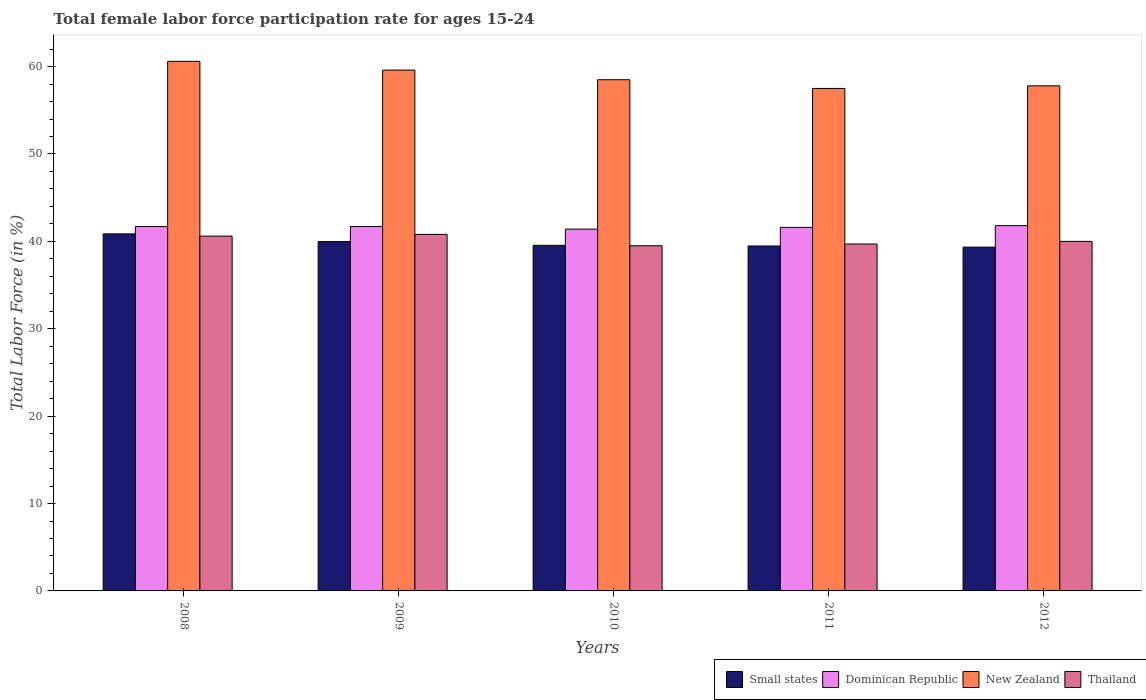How many bars are there on the 1st tick from the right?
Your response must be concise. 4. In how many cases, is the number of bars for a given year not equal to the number of legend labels?
Offer a terse response. 0. What is the female labor force participation rate in Thailand in 2009?
Your response must be concise. 40.8. Across all years, what is the maximum female labor force participation rate in Dominican Republic?
Ensure brevity in your answer.  41.8. Across all years, what is the minimum female labor force participation rate in Thailand?
Your answer should be very brief. 39.5. In which year was the female labor force participation rate in Small states maximum?
Offer a terse response. 2008. What is the total female labor force participation rate in New Zealand in the graph?
Offer a very short reply. 294. What is the difference between the female labor force participation rate in Thailand in 2009 and that in 2012?
Ensure brevity in your answer.  0.8. What is the difference between the female labor force participation rate in New Zealand in 2011 and the female labor force participation rate in Small states in 2012?
Make the answer very short. 18.16. What is the average female labor force participation rate in New Zealand per year?
Your answer should be compact. 58.8. In the year 2012, what is the difference between the female labor force participation rate in Thailand and female labor force participation rate in Dominican Republic?
Give a very brief answer. -1.8. What is the ratio of the female labor force participation rate in Thailand in 2009 to that in 2010?
Ensure brevity in your answer.  1.03. Is the difference between the female labor force participation rate in Thailand in 2009 and 2011 greater than the difference between the female labor force participation rate in Dominican Republic in 2009 and 2011?
Provide a succinct answer. Yes. What is the difference between the highest and the second highest female labor force participation rate in Small states?
Your answer should be very brief. 0.88. What is the difference between the highest and the lowest female labor force participation rate in Dominican Republic?
Your response must be concise. 0.4. In how many years, is the female labor force participation rate in Small states greater than the average female labor force participation rate in Small states taken over all years?
Offer a terse response. 2. Is the sum of the female labor force participation rate in Thailand in 2009 and 2012 greater than the maximum female labor force participation rate in Dominican Republic across all years?
Your answer should be compact. Yes. What does the 2nd bar from the left in 2010 represents?
Ensure brevity in your answer.  Dominican Republic. What does the 1st bar from the right in 2009 represents?
Provide a short and direct response. Thailand. Is it the case that in every year, the sum of the female labor force participation rate in Thailand and female labor force participation rate in Dominican Republic is greater than the female labor force participation rate in Small states?
Provide a succinct answer. Yes. How many bars are there?
Ensure brevity in your answer.  20. How many years are there in the graph?
Ensure brevity in your answer.  5. What is the difference between two consecutive major ticks on the Y-axis?
Your response must be concise. 10. Are the values on the major ticks of Y-axis written in scientific E-notation?
Your answer should be compact. No. Does the graph contain any zero values?
Ensure brevity in your answer.  No. How are the legend labels stacked?
Your answer should be compact. Horizontal. What is the title of the graph?
Your answer should be very brief. Total female labor force participation rate for ages 15-24. Does "United Arab Emirates" appear as one of the legend labels in the graph?
Make the answer very short. No. What is the label or title of the Y-axis?
Keep it short and to the point. Total Labor Force (in %). What is the Total Labor Force (in %) in Small states in 2008?
Make the answer very short. 40.86. What is the Total Labor Force (in %) of Dominican Republic in 2008?
Keep it short and to the point. 41.7. What is the Total Labor Force (in %) of New Zealand in 2008?
Provide a succinct answer. 60.6. What is the Total Labor Force (in %) in Thailand in 2008?
Make the answer very short. 40.6. What is the Total Labor Force (in %) in Small states in 2009?
Provide a short and direct response. 39.97. What is the Total Labor Force (in %) of Dominican Republic in 2009?
Provide a succinct answer. 41.7. What is the Total Labor Force (in %) in New Zealand in 2009?
Your answer should be very brief. 59.6. What is the Total Labor Force (in %) of Thailand in 2009?
Your answer should be very brief. 40.8. What is the Total Labor Force (in %) of Small states in 2010?
Provide a short and direct response. 39.54. What is the Total Labor Force (in %) of Dominican Republic in 2010?
Give a very brief answer. 41.4. What is the Total Labor Force (in %) of New Zealand in 2010?
Your answer should be compact. 58.5. What is the Total Labor Force (in %) of Thailand in 2010?
Your answer should be compact. 39.5. What is the Total Labor Force (in %) of Small states in 2011?
Make the answer very short. 39.47. What is the Total Labor Force (in %) in Dominican Republic in 2011?
Ensure brevity in your answer.  41.6. What is the Total Labor Force (in %) in New Zealand in 2011?
Give a very brief answer. 57.5. What is the Total Labor Force (in %) in Thailand in 2011?
Keep it short and to the point. 39.7. What is the Total Labor Force (in %) in Small states in 2012?
Ensure brevity in your answer.  39.34. What is the Total Labor Force (in %) in Dominican Republic in 2012?
Your answer should be very brief. 41.8. What is the Total Labor Force (in %) in New Zealand in 2012?
Offer a terse response. 57.8. What is the Total Labor Force (in %) of Thailand in 2012?
Provide a short and direct response. 40. Across all years, what is the maximum Total Labor Force (in %) in Small states?
Offer a terse response. 40.86. Across all years, what is the maximum Total Labor Force (in %) in Dominican Republic?
Provide a short and direct response. 41.8. Across all years, what is the maximum Total Labor Force (in %) in New Zealand?
Your answer should be compact. 60.6. Across all years, what is the maximum Total Labor Force (in %) of Thailand?
Offer a very short reply. 40.8. Across all years, what is the minimum Total Labor Force (in %) in Small states?
Ensure brevity in your answer.  39.34. Across all years, what is the minimum Total Labor Force (in %) in Dominican Republic?
Ensure brevity in your answer.  41.4. Across all years, what is the minimum Total Labor Force (in %) in New Zealand?
Offer a very short reply. 57.5. Across all years, what is the minimum Total Labor Force (in %) in Thailand?
Keep it short and to the point. 39.5. What is the total Total Labor Force (in %) of Small states in the graph?
Keep it short and to the point. 199.19. What is the total Total Labor Force (in %) of Dominican Republic in the graph?
Offer a terse response. 208.2. What is the total Total Labor Force (in %) in New Zealand in the graph?
Give a very brief answer. 294. What is the total Total Labor Force (in %) of Thailand in the graph?
Your answer should be very brief. 200.6. What is the difference between the Total Labor Force (in %) of Small states in 2008 and that in 2009?
Offer a very short reply. 0.88. What is the difference between the Total Labor Force (in %) of Dominican Republic in 2008 and that in 2009?
Keep it short and to the point. 0. What is the difference between the Total Labor Force (in %) of New Zealand in 2008 and that in 2009?
Your answer should be very brief. 1. What is the difference between the Total Labor Force (in %) in Small states in 2008 and that in 2010?
Keep it short and to the point. 1.31. What is the difference between the Total Labor Force (in %) of Small states in 2008 and that in 2011?
Ensure brevity in your answer.  1.39. What is the difference between the Total Labor Force (in %) in Dominican Republic in 2008 and that in 2011?
Your answer should be compact. 0.1. What is the difference between the Total Labor Force (in %) in New Zealand in 2008 and that in 2011?
Offer a very short reply. 3.1. What is the difference between the Total Labor Force (in %) in Small states in 2008 and that in 2012?
Offer a very short reply. 1.52. What is the difference between the Total Labor Force (in %) of Dominican Republic in 2008 and that in 2012?
Your answer should be very brief. -0.1. What is the difference between the Total Labor Force (in %) of Small states in 2009 and that in 2010?
Provide a short and direct response. 0.43. What is the difference between the Total Labor Force (in %) in Thailand in 2009 and that in 2010?
Ensure brevity in your answer.  1.3. What is the difference between the Total Labor Force (in %) in Small states in 2009 and that in 2011?
Your answer should be very brief. 0.5. What is the difference between the Total Labor Force (in %) in New Zealand in 2009 and that in 2011?
Offer a terse response. 2.1. What is the difference between the Total Labor Force (in %) of Small states in 2009 and that in 2012?
Offer a terse response. 0.63. What is the difference between the Total Labor Force (in %) in Small states in 2010 and that in 2011?
Your answer should be compact. 0.07. What is the difference between the Total Labor Force (in %) of Dominican Republic in 2010 and that in 2011?
Provide a succinct answer. -0.2. What is the difference between the Total Labor Force (in %) of Thailand in 2010 and that in 2011?
Make the answer very short. -0.2. What is the difference between the Total Labor Force (in %) of Small states in 2010 and that in 2012?
Make the answer very short. 0.2. What is the difference between the Total Labor Force (in %) of Dominican Republic in 2010 and that in 2012?
Keep it short and to the point. -0.4. What is the difference between the Total Labor Force (in %) in Small states in 2011 and that in 2012?
Your answer should be compact. 0.13. What is the difference between the Total Labor Force (in %) in New Zealand in 2011 and that in 2012?
Offer a terse response. -0.3. What is the difference between the Total Labor Force (in %) of Thailand in 2011 and that in 2012?
Give a very brief answer. -0.3. What is the difference between the Total Labor Force (in %) in Small states in 2008 and the Total Labor Force (in %) in Dominican Republic in 2009?
Provide a succinct answer. -0.84. What is the difference between the Total Labor Force (in %) of Small states in 2008 and the Total Labor Force (in %) of New Zealand in 2009?
Make the answer very short. -18.74. What is the difference between the Total Labor Force (in %) in Small states in 2008 and the Total Labor Force (in %) in Thailand in 2009?
Offer a very short reply. 0.06. What is the difference between the Total Labor Force (in %) in Dominican Republic in 2008 and the Total Labor Force (in %) in New Zealand in 2009?
Keep it short and to the point. -17.9. What is the difference between the Total Labor Force (in %) in New Zealand in 2008 and the Total Labor Force (in %) in Thailand in 2009?
Ensure brevity in your answer.  19.8. What is the difference between the Total Labor Force (in %) in Small states in 2008 and the Total Labor Force (in %) in Dominican Republic in 2010?
Offer a terse response. -0.54. What is the difference between the Total Labor Force (in %) in Small states in 2008 and the Total Labor Force (in %) in New Zealand in 2010?
Offer a terse response. -17.64. What is the difference between the Total Labor Force (in %) of Small states in 2008 and the Total Labor Force (in %) of Thailand in 2010?
Offer a very short reply. 1.36. What is the difference between the Total Labor Force (in %) of Dominican Republic in 2008 and the Total Labor Force (in %) of New Zealand in 2010?
Give a very brief answer. -16.8. What is the difference between the Total Labor Force (in %) in New Zealand in 2008 and the Total Labor Force (in %) in Thailand in 2010?
Offer a very short reply. 21.1. What is the difference between the Total Labor Force (in %) in Small states in 2008 and the Total Labor Force (in %) in Dominican Republic in 2011?
Ensure brevity in your answer.  -0.74. What is the difference between the Total Labor Force (in %) in Small states in 2008 and the Total Labor Force (in %) in New Zealand in 2011?
Keep it short and to the point. -16.64. What is the difference between the Total Labor Force (in %) in Small states in 2008 and the Total Labor Force (in %) in Thailand in 2011?
Offer a very short reply. 1.16. What is the difference between the Total Labor Force (in %) of Dominican Republic in 2008 and the Total Labor Force (in %) of New Zealand in 2011?
Make the answer very short. -15.8. What is the difference between the Total Labor Force (in %) of Dominican Republic in 2008 and the Total Labor Force (in %) of Thailand in 2011?
Ensure brevity in your answer.  2. What is the difference between the Total Labor Force (in %) of New Zealand in 2008 and the Total Labor Force (in %) of Thailand in 2011?
Give a very brief answer. 20.9. What is the difference between the Total Labor Force (in %) in Small states in 2008 and the Total Labor Force (in %) in Dominican Republic in 2012?
Keep it short and to the point. -0.94. What is the difference between the Total Labor Force (in %) of Small states in 2008 and the Total Labor Force (in %) of New Zealand in 2012?
Your response must be concise. -16.94. What is the difference between the Total Labor Force (in %) of Small states in 2008 and the Total Labor Force (in %) of Thailand in 2012?
Your answer should be very brief. 0.86. What is the difference between the Total Labor Force (in %) in Dominican Republic in 2008 and the Total Labor Force (in %) in New Zealand in 2012?
Your answer should be compact. -16.1. What is the difference between the Total Labor Force (in %) in Dominican Republic in 2008 and the Total Labor Force (in %) in Thailand in 2012?
Your answer should be compact. 1.7. What is the difference between the Total Labor Force (in %) of New Zealand in 2008 and the Total Labor Force (in %) of Thailand in 2012?
Provide a short and direct response. 20.6. What is the difference between the Total Labor Force (in %) of Small states in 2009 and the Total Labor Force (in %) of Dominican Republic in 2010?
Offer a terse response. -1.43. What is the difference between the Total Labor Force (in %) of Small states in 2009 and the Total Labor Force (in %) of New Zealand in 2010?
Provide a succinct answer. -18.53. What is the difference between the Total Labor Force (in %) in Small states in 2009 and the Total Labor Force (in %) in Thailand in 2010?
Ensure brevity in your answer.  0.47. What is the difference between the Total Labor Force (in %) of Dominican Republic in 2009 and the Total Labor Force (in %) of New Zealand in 2010?
Your response must be concise. -16.8. What is the difference between the Total Labor Force (in %) of New Zealand in 2009 and the Total Labor Force (in %) of Thailand in 2010?
Keep it short and to the point. 20.1. What is the difference between the Total Labor Force (in %) in Small states in 2009 and the Total Labor Force (in %) in Dominican Republic in 2011?
Provide a short and direct response. -1.63. What is the difference between the Total Labor Force (in %) in Small states in 2009 and the Total Labor Force (in %) in New Zealand in 2011?
Give a very brief answer. -17.53. What is the difference between the Total Labor Force (in %) in Small states in 2009 and the Total Labor Force (in %) in Thailand in 2011?
Offer a terse response. 0.27. What is the difference between the Total Labor Force (in %) in Dominican Republic in 2009 and the Total Labor Force (in %) in New Zealand in 2011?
Offer a very short reply. -15.8. What is the difference between the Total Labor Force (in %) in Dominican Republic in 2009 and the Total Labor Force (in %) in Thailand in 2011?
Provide a short and direct response. 2. What is the difference between the Total Labor Force (in %) of New Zealand in 2009 and the Total Labor Force (in %) of Thailand in 2011?
Ensure brevity in your answer.  19.9. What is the difference between the Total Labor Force (in %) of Small states in 2009 and the Total Labor Force (in %) of Dominican Republic in 2012?
Offer a terse response. -1.83. What is the difference between the Total Labor Force (in %) in Small states in 2009 and the Total Labor Force (in %) in New Zealand in 2012?
Your answer should be compact. -17.83. What is the difference between the Total Labor Force (in %) of Small states in 2009 and the Total Labor Force (in %) of Thailand in 2012?
Keep it short and to the point. -0.03. What is the difference between the Total Labor Force (in %) of Dominican Republic in 2009 and the Total Labor Force (in %) of New Zealand in 2012?
Keep it short and to the point. -16.1. What is the difference between the Total Labor Force (in %) of Dominican Republic in 2009 and the Total Labor Force (in %) of Thailand in 2012?
Provide a succinct answer. 1.7. What is the difference between the Total Labor Force (in %) of New Zealand in 2009 and the Total Labor Force (in %) of Thailand in 2012?
Provide a succinct answer. 19.6. What is the difference between the Total Labor Force (in %) of Small states in 2010 and the Total Labor Force (in %) of Dominican Republic in 2011?
Your answer should be very brief. -2.06. What is the difference between the Total Labor Force (in %) of Small states in 2010 and the Total Labor Force (in %) of New Zealand in 2011?
Make the answer very short. -17.96. What is the difference between the Total Labor Force (in %) in Small states in 2010 and the Total Labor Force (in %) in Thailand in 2011?
Make the answer very short. -0.16. What is the difference between the Total Labor Force (in %) in Dominican Republic in 2010 and the Total Labor Force (in %) in New Zealand in 2011?
Provide a succinct answer. -16.1. What is the difference between the Total Labor Force (in %) in Dominican Republic in 2010 and the Total Labor Force (in %) in Thailand in 2011?
Provide a succinct answer. 1.7. What is the difference between the Total Labor Force (in %) of New Zealand in 2010 and the Total Labor Force (in %) of Thailand in 2011?
Offer a very short reply. 18.8. What is the difference between the Total Labor Force (in %) of Small states in 2010 and the Total Labor Force (in %) of Dominican Republic in 2012?
Your answer should be very brief. -2.26. What is the difference between the Total Labor Force (in %) of Small states in 2010 and the Total Labor Force (in %) of New Zealand in 2012?
Give a very brief answer. -18.26. What is the difference between the Total Labor Force (in %) in Small states in 2010 and the Total Labor Force (in %) in Thailand in 2012?
Offer a terse response. -0.46. What is the difference between the Total Labor Force (in %) of Dominican Republic in 2010 and the Total Labor Force (in %) of New Zealand in 2012?
Give a very brief answer. -16.4. What is the difference between the Total Labor Force (in %) in New Zealand in 2010 and the Total Labor Force (in %) in Thailand in 2012?
Your answer should be very brief. 18.5. What is the difference between the Total Labor Force (in %) in Small states in 2011 and the Total Labor Force (in %) in Dominican Republic in 2012?
Your answer should be compact. -2.33. What is the difference between the Total Labor Force (in %) of Small states in 2011 and the Total Labor Force (in %) of New Zealand in 2012?
Make the answer very short. -18.33. What is the difference between the Total Labor Force (in %) of Small states in 2011 and the Total Labor Force (in %) of Thailand in 2012?
Your answer should be very brief. -0.53. What is the difference between the Total Labor Force (in %) in Dominican Republic in 2011 and the Total Labor Force (in %) in New Zealand in 2012?
Keep it short and to the point. -16.2. What is the difference between the Total Labor Force (in %) of New Zealand in 2011 and the Total Labor Force (in %) of Thailand in 2012?
Your response must be concise. 17.5. What is the average Total Labor Force (in %) of Small states per year?
Give a very brief answer. 39.84. What is the average Total Labor Force (in %) of Dominican Republic per year?
Ensure brevity in your answer.  41.64. What is the average Total Labor Force (in %) in New Zealand per year?
Your answer should be very brief. 58.8. What is the average Total Labor Force (in %) in Thailand per year?
Offer a very short reply. 40.12. In the year 2008, what is the difference between the Total Labor Force (in %) of Small states and Total Labor Force (in %) of Dominican Republic?
Offer a terse response. -0.84. In the year 2008, what is the difference between the Total Labor Force (in %) of Small states and Total Labor Force (in %) of New Zealand?
Provide a short and direct response. -19.74. In the year 2008, what is the difference between the Total Labor Force (in %) in Small states and Total Labor Force (in %) in Thailand?
Give a very brief answer. 0.26. In the year 2008, what is the difference between the Total Labor Force (in %) of Dominican Republic and Total Labor Force (in %) of New Zealand?
Make the answer very short. -18.9. In the year 2008, what is the difference between the Total Labor Force (in %) of Dominican Republic and Total Labor Force (in %) of Thailand?
Keep it short and to the point. 1.1. In the year 2008, what is the difference between the Total Labor Force (in %) in New Zealand and Total Labor Force (in %) in Thailand?
Your answer should be very brief. 20. In the year 2009, what is the difference between the Total Labor Force (in %) of Small states and Total Labor Force (in %) of Dominican Republic?
Make the answer very short. -1.73. In the year 2009, what is the difference between the Total Labor Force (in %) in Small states and Total Labor Force (in %) in New Zealand?
Your response must be concise. -19.63. In the year 2009, what is the difference between the Total Labor Force (in %) in Small states and Total Labor Force (in %) in Thailand?
Provide a short and direct response. -0.83. In the year 2009, what is the difference between the Total Labor Force (in %) of Dominican Republic and Total Labor Force (in %) of New Zealand?
Offer a terse response. -17.9. In the year 2009, what is the difference between the Total Labor Force (in %) of Dominican Republic and Total Labor Force (in %) of Thailand?
Offer a terse response. 0.9. In the year 2009, what is the difference between the Total Labor Force (in %) of New Zealand and Total Labor Force (in %) of Thailand?
Provide a short and direct response. 18.8. In the year 2010, what is the difference between the Total Labor Force (in %) in Small states and Total Labor Force (in %) in Dominican Republic?
Give a very brief answer. -1.86. In the year 2010, what is the difference between the Total Labor Force (in %) in Small states and Total Labor Force (in %) in New Zealand?
Your answer should be very brief. -18.96. In the year 2010, what is the difference between the Total Labor Force (in %) in Small states and Total Labor Force (in %) in Thailand?
Offer a terse response. 0.04. In the year 2010, what is the difference between the Total Labor Force (in %) of Dominican Republic and Total Labor Force (in %) of New Zealand?
Your response must be concise. -17.1. In the year 2010, what is the difference between the Total Labor Force (in %) in Dominican Republic and Total Labor Force (in %) in Thailand?
Your answer should be compact. 1.9. In the year 2010, what is the difference between the Total Labor Force (in %) in New Zealand and Total Labor Force (in %) in Thailand?
Your answer should be very brief. 19. In the year 2011, what is the difference between the Total Labor Force (in %) of Small states and Total Labor Force (in %) of Dominican Republic?
Offer a very short reply. -2.13. In the year 2011, what is the difference between the Total Labor Force (in %) of Small states and Total Labor Force (in %) of New Zealand?
Your answer should be very brief. -18.03. In the year 2011, what is the difference between the Total Labor Force (in %) of Small states and Total Labor Force (in %) of Thailand?
Provide a short and direct response. -0.23. In the year 2011, what is the difference between the Total Labor Force (in %) in Dominican Republic and Total Labor Force (in %) in New Zealand?
Your answer should be very brief. -15.9. In the year 2011, what is the difference between the Total Labor Force (in %) of New Zealand and Total Labor Force (in %) of Thailand?
Offer a terse response. 17.8. In the year 2012, what is the difference between the Total Labor Force (in %) of Small states and Total Labor Force (in %) of Dominican Republic?
Your answer should be compact. -2.46. In the year 2012, what is the difference between the Total Labor Force (in %) of Small states and Total Labor Force (in %) of New Zealand?
Make the answer very short. -18.46. In the year 2012, what is the difference between the Total Labor Force (in %) of Small states and Total Labor Force (in %) of Thailand?
Give a very brief answer. -0.66. In the year 2012, what is the difference between the Total Labor Force (in %) in New Zealand and Total Labor Force (in %) in Thailand?
Ensure brevity in your answer.  17.8. What is the ratio of the Total Labor Force (in %) in Small states in 2008 to that in 2009?
Keep it short and to the point. 1.02. What is the ratio of the Total Labor Force (in %) of Dominican Republic in 2008 to that in 2009?
Provide a short and direct response. 1. What is the ratio of the Total Labor Force (in %) of New Zealand in 2008 to that in 2009?
Ensure brevity in your answer.  1.02. What is the ratio of the Total Labor Force (in %) of Small states in 2008 to that in 2010?
Provide a short and direct response. 1.03. What is the ratio of the Total Labor Force (in %) of New Zealand in 2008 to that in 2010?
Provide a succinct answer. 1.04. What is the ratio of the Total Labor Force (in %) in Thailand in 2008 to that in 2010?
Offer a very short reply. 1.03. What is the ratio of the Total Labor Force (in %) of Small states in 2008 to that in 2011?
Give a very brief answer. 1.04. What is the ratio of the Total Labor Force (in %) in New Zealand in 2008 to that in 2011?
Ensure brevity in your answer.  1.05. What is the ratio of the Total Labor Force (in %) of Thailand in 2008 to that in 2011?
Offer a very short reply. 1.02. What is the ratio of the Total Labor Force (in %) of Small states in 2008 to that in 2012?
Offer a very short reply. 1.04. What is the ratio of the Total Labor Force (in %) of New Zealand in 2008 to that in 2012?
Your answer should be compact. 1.05. What is the ratio of the Total Labor Force (in %) of Small states in 2009 to that in 2010?
Make the answer very short. 1.01. What is the ratio of the Total Labor Force (in %) of Dominican Republic in 2009 to that in 2010?
Your response must be concise. 1.01. What is the ratio of the Total Labor Force (in %) in New Zealand in 2009 to that in 2010?
Ensure brevity in your answer.  1.02. What is the ratio of the Total Labor Force (in %) in Thailand in 2009 to that in 2010?
Your answer should be very brief. 1.03. What is the ratio of the Total Labor Force (in %) of Small states in 2009 to that in 2011?
Give a very brief answer. 1.01. What is the ratio of the Total Labor Force (in %) of New Zealand in 2009 to that in 2011?
Provide a succinct answer. 1.04. What is the ratio of the Total Labor Force (in %) in Thailand in 2009 to that in 2011?
Provide a succinct answer. 1.03. What is the ratio of the Total Labor Force (in %) of Small states in 2009 to that in 2012?
Offer a very short reply. 1.02. What is the ratio of the Total Labor Force (in %) of New Zealand in 2009 to that in 2012?
Provide a short and direct response. 1.03. What is the ratio of the Total Labor Force (in %) in Thailand in 2009 to that in 2012?
Offer a very short reply. 1.02. What is the ratio of the Total Labor Force (in %) in Dominican Republic in 2010 to that in 2011?
Provide a succinct answer. 1. What is the ratio of the Total Labor Force (in %) of New Zealand in 2010 to that in 2011?
Offer a very short reply. 1.02. What is the ratio of the Total Labor Force (in %) of Thailand in 2010 to that in 2011?
Your response must be concise. 0.99. What is the ratio of the Total Labor Force (in %) in Small states in 2010 to that in 2012?
Provide a succinct answer. 1.01. What is the ratio of the Total Labor Force (in %) of Dominican Republic in 2010 to that in 2012?
Your answer should be compact. 0.99. What is the ratio of the Total Labor Force (in %) in New Zealand in 2010 to that in 2012?
Offer a terse response. 1.01. What is the ratio of the Total Labor Force (in %) in Thailand in 2010 to that in 2012?
Ensure brevity in your answer.  0.99. What is the ratio of the Total Labor Force (in %) of Dominican Republic in 2011 to that in 2012?
Ensure brevity in your answer.  1. What is the ratio of the Total Labor Force (in %) of Thailand in 2011 to that in 2012?
Give a very brief answer. 0.99. What is the difference between the highest and the second highest Total Labor Force (in %) in Small states?
Your response must be concise. 0.88. What is the difference between the highest and the second highest Total Labor Force (in %) of Thailand?
Your response must be concise. 0.2. What is the difference between the highest and the lowest Total Labor Force (in %) in Small states?
Your answer should be compact. 1.52. 